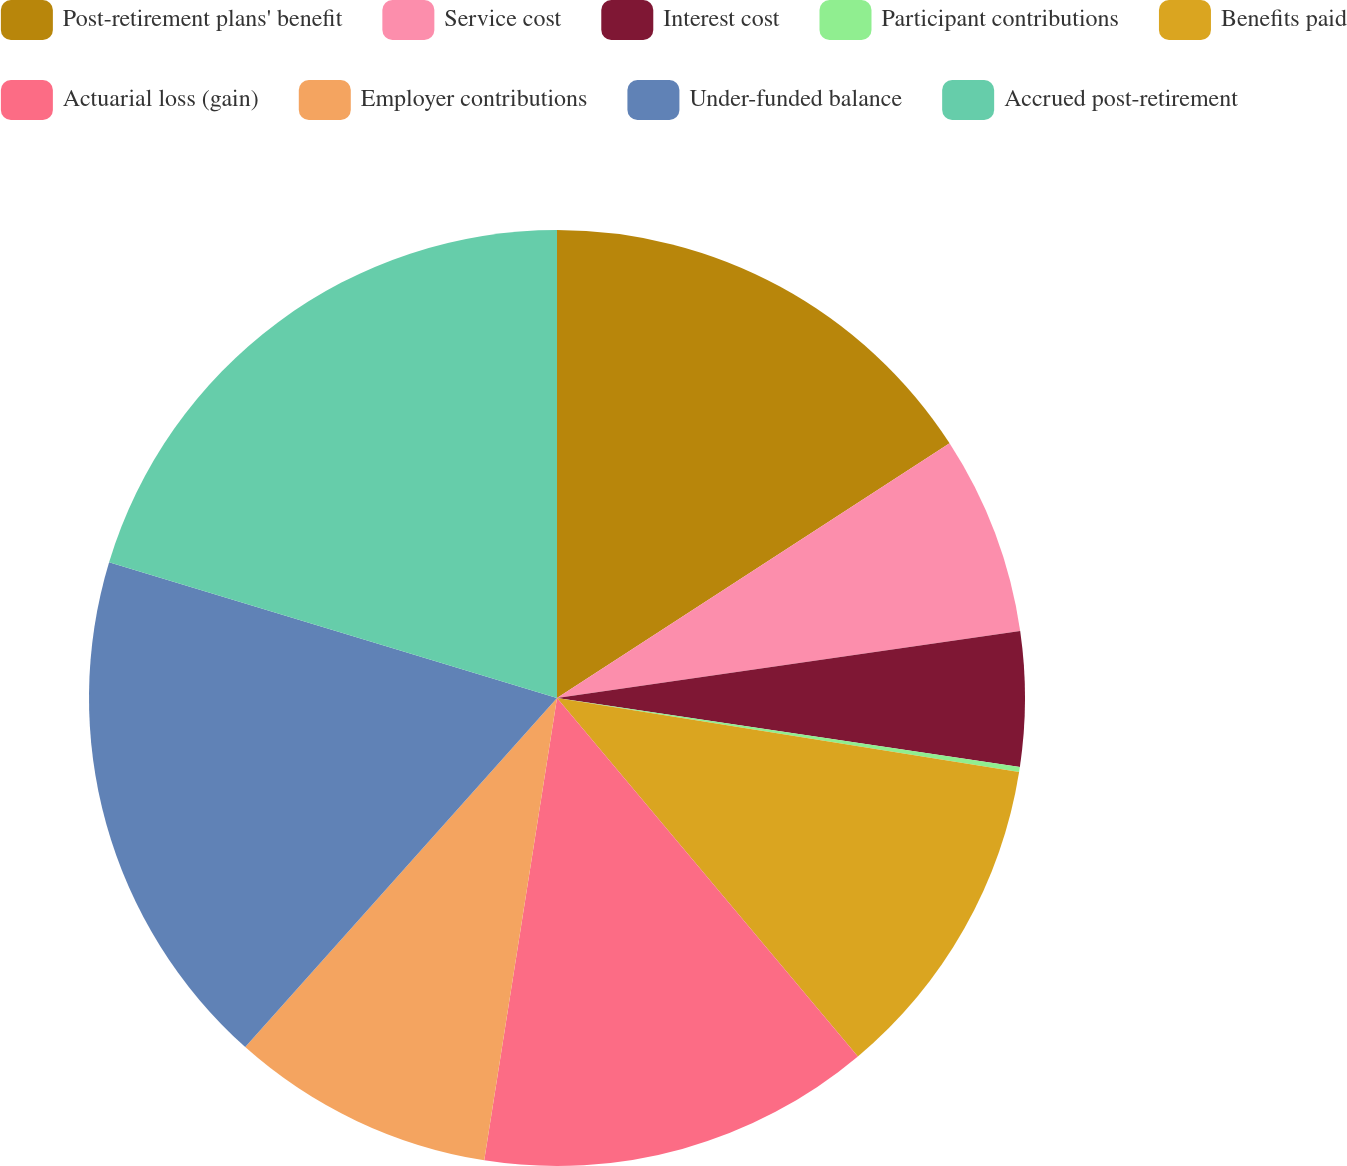Convert chart. <chart><loc_0><loc_0><loc_500><loc_500><pie_chart><fcel>Post-retirement plans' benefit<fcel>Service cost<fcel>Interest cost<fcel>Participant contributions<fcel>Benefits paid<fcel>Actuarial loss (gain)<fcel>Employer contributions<fcel>Under-funded balance<fcel>Accrued post-retirement<nl><fcel>15.84%<fcel>6.88%<fcel>4.64%<fcel>0.17%<fcel>11.36%<fcel>13.6%<fcel>9.12%<fcel>18.08%<fcel>20.32%<nl></chart> 